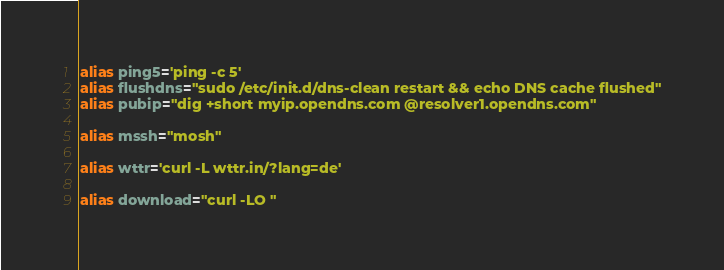Convert code to text. <code><loc_0><loc_0><loc_500><loc_500><_Bash_>alias ping5='ping -c 5'
alias flushdns="sudo /etc/init.d/dns-clean restart && echo DNS cache flushed"
alias pubip="dig +short myip.opendns.com @resolver1.opendns.com"

alias mssh="mosh"

alias wttr='curl -L wttr.in/?lang=de'

alias download="curl -LO "
</code> 